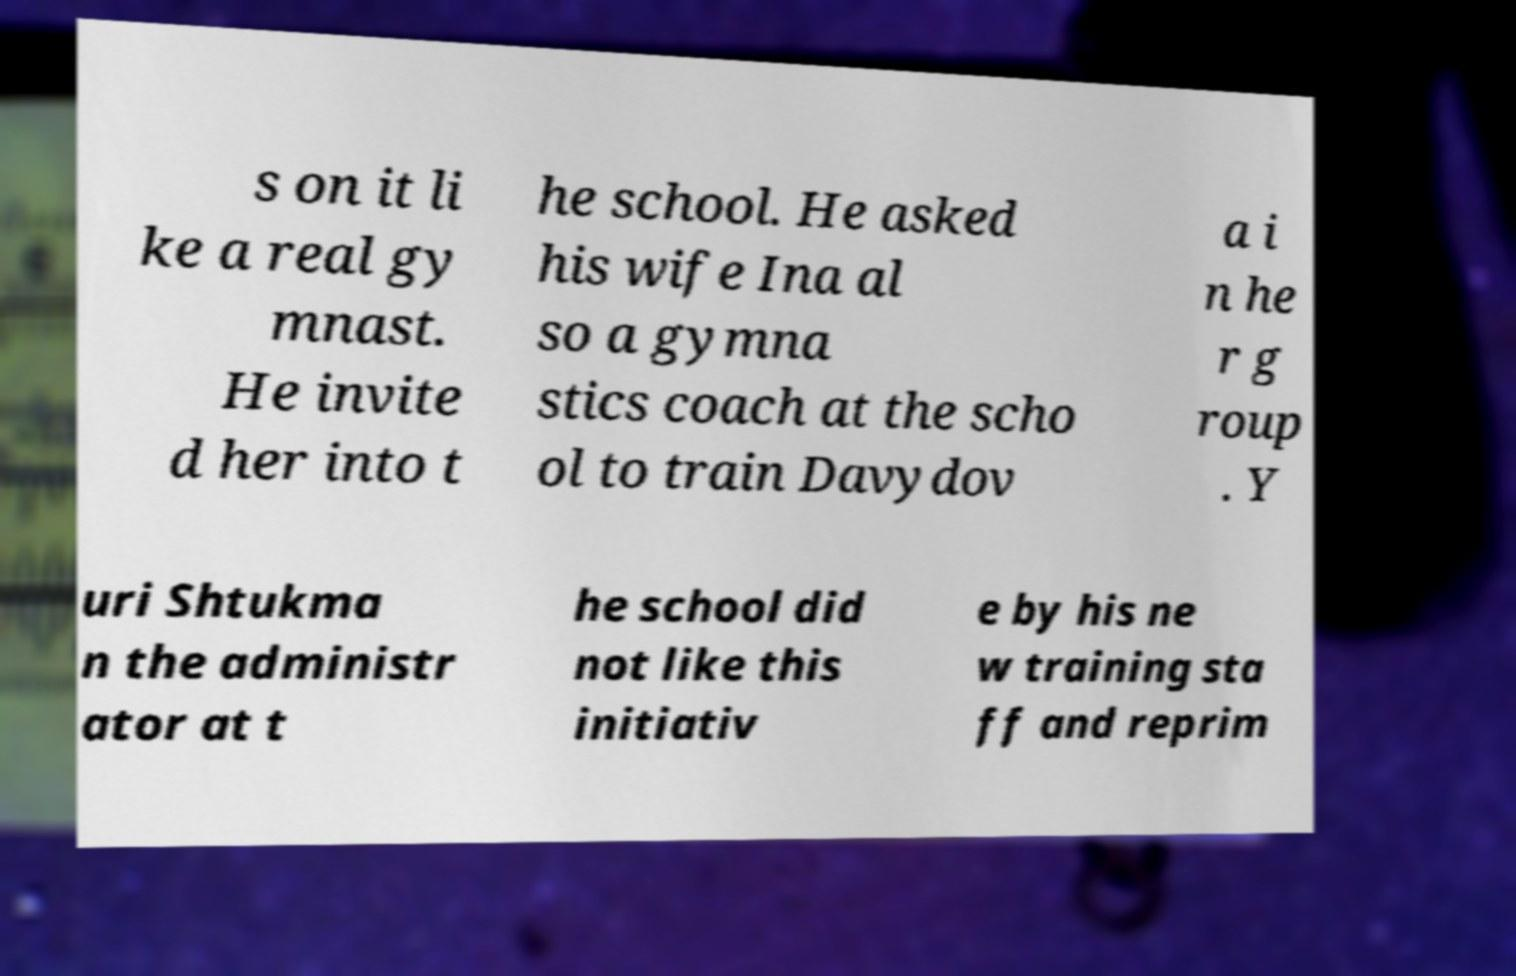Can you accurately transcribe the text from the provided image for me? s on it li ke a real gy mnast. He invite d her into t he school. He asked his wife Ina al so a gymna stics coach at the scho ol to train Davydov a i n he r g roup . Y uri Shtukma n the administr ator at t he school did not like this initiativ e by his ne w training sta ff and reprim 